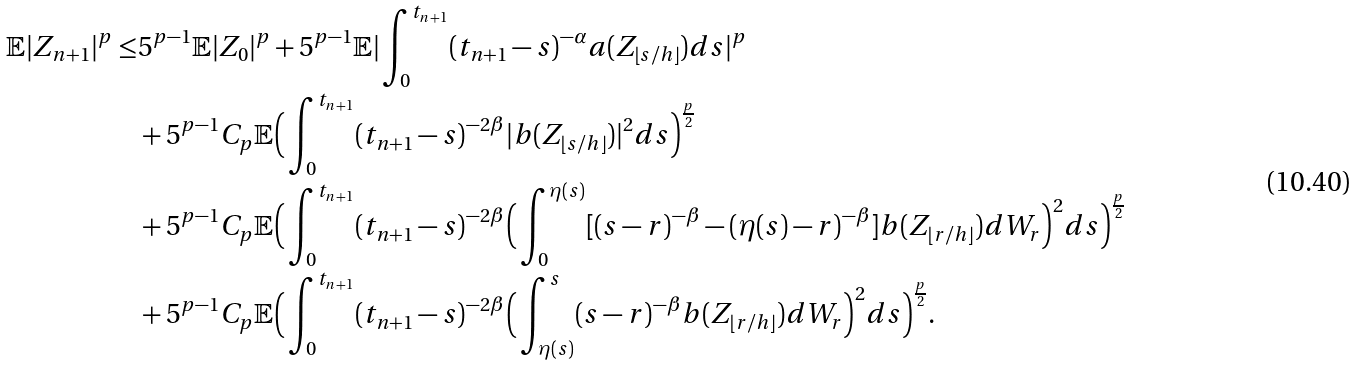<formula> <loc_0><loc_0><loc_500><loc_500>\mathbb { E } | Z _ { n + 1 } | ^ { p } \leq & 5 ^ { p - 1 } \mathbb { E } | Z _ { 0 } | ^ { p } + 5 ^ { p - 1 } \mathbb { E } | \int _ { 0 } ^ { t _ { n + 1 } } ( t _ { n + 1 } - s ) ^ { - \alpha } a ( Z _ { \lfloor s / h \rfloor } ) d s | ^ { p } \\ & + 5 ^ { p - 1 } C _ { p } \mathbb { E } \Big { ( } \int _ { 0 } ^ { t _ { n + 1 } } ( t _ { n + 1 } - s ) ^ { - 2 \beta } | b ( Z _ { \lfloor s / h \rfloor } ) | ^ { 2 } d s \Big { ) } ^ { \frac { p } { 2 } } \\ & + 5 ^ { p - 1 } C _ { p } \mathbb { E } \Big { ( } \int _ { 0 } ^ { t _ { n + 1 } } ( t _ { n + 1 } - s ) ^ { - 2 \beta } \Big { ( } \int _ { 0 } ^ { \eta ( s ) } [ ( s - r ) ^ { - \beta } - ( \eta ( s ) - r ) ^ { - \beta } ] b ( Z _ { \lfloor r / h \rfloor } ) d W _ { r } \Big { ) } ^ { 2 } d s \Big { ) } ^ { \frac { p } { 2 } } \\ & + 5 ^ { p - 1 } C _ { p } \mathbb { E } \Big { ( } \int _ { 0 } ^ { t _ { n + 1 } } ( t _ { n + 1 } - s ) ^ { - 2 \beta } \Big { ( } \int _ { \eta ( s ) } ^ { s } ( s - r ) ^ { - \beta } b ( Z _ { \lfloor r / h \rfloor } ) d W _ { r } \Big { ) } ^ { 2 } d s \Big { ) } ^ { \frac { p } { 2 } } .</formula> 